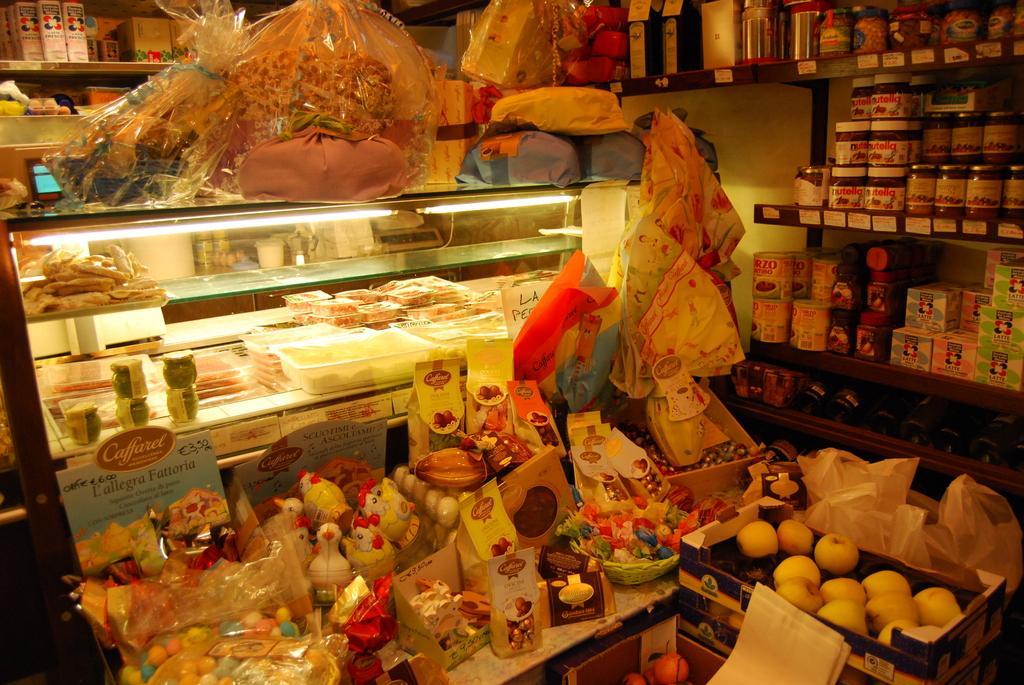Describe this image in one or two sentences. In this image there is a table, on that table there are chocolates, toffees, toys, in the background there is a glass box in that box there are bakery items, on top of the box there are gift packs, in the bottom right there are fruits in a box, in the background there are racks, in that racks there are few objects. 